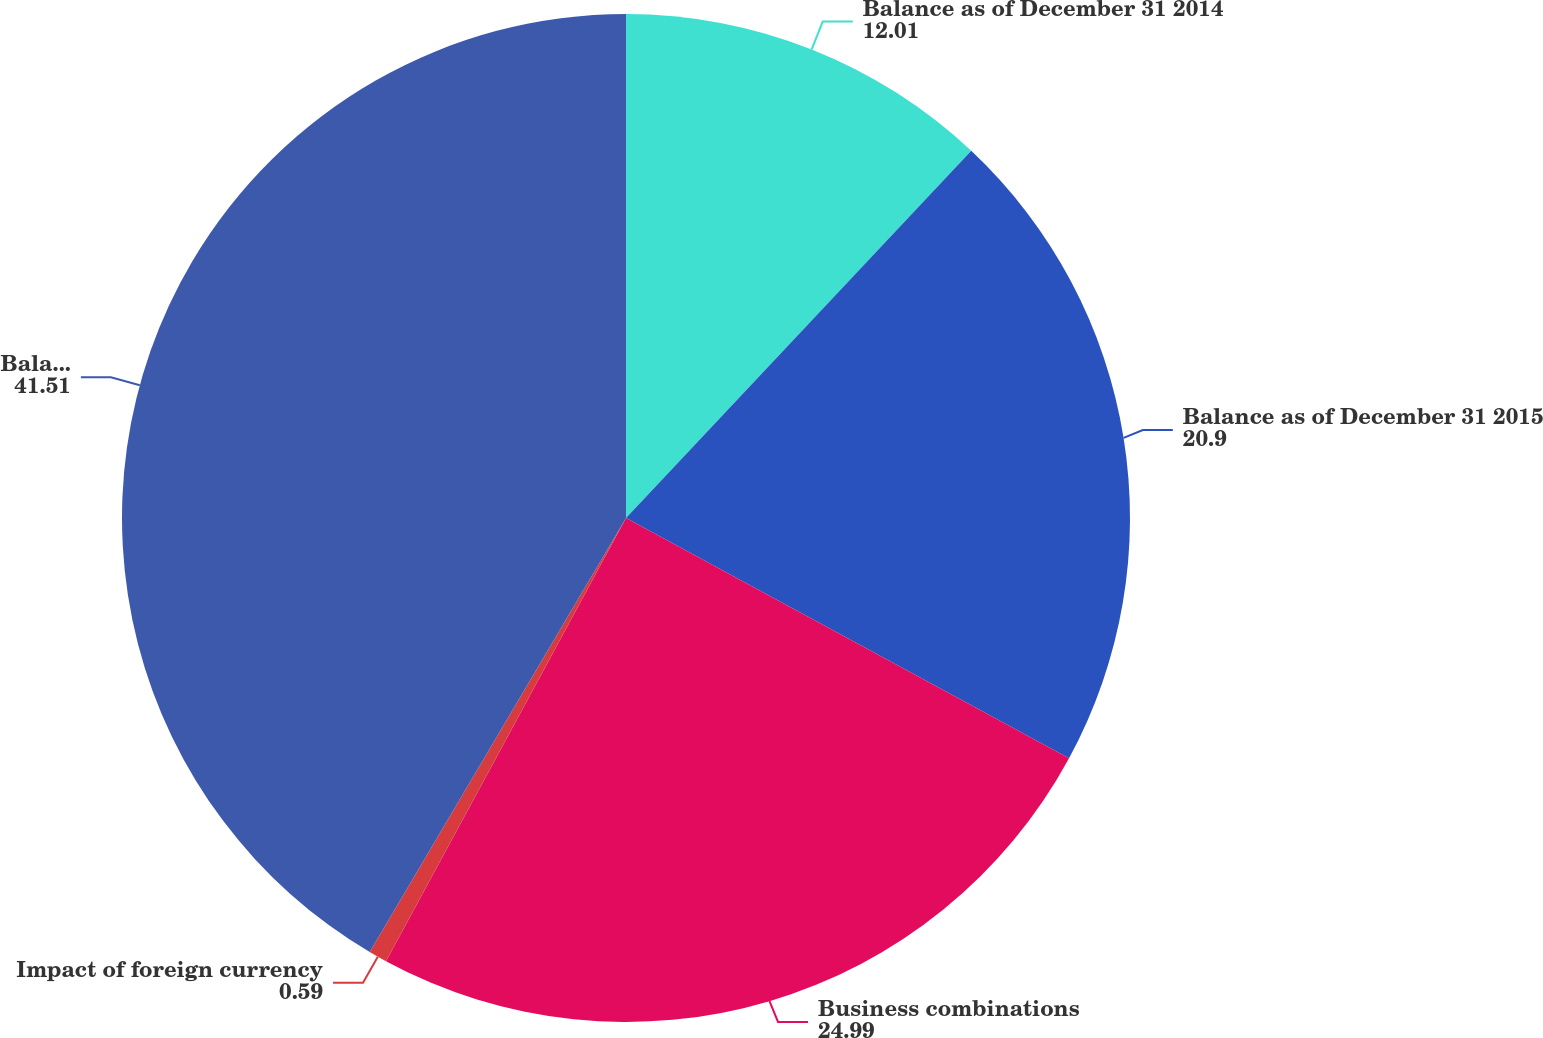<chart> <loc_0><loc_0><loc_500><loc_500><pie_chart><fcel>Balance as of December 31 2014<fcel>Balance as of December 31 2015<fcel>Business combinations<fcel>Impact of foreign currency<fcel>Balance as of December 31 2016<nl><fcel>12.01%<fcel>20.9%<fcel>24.99%<fcel>0.59%<fcel>41.51%<nl></chart> 